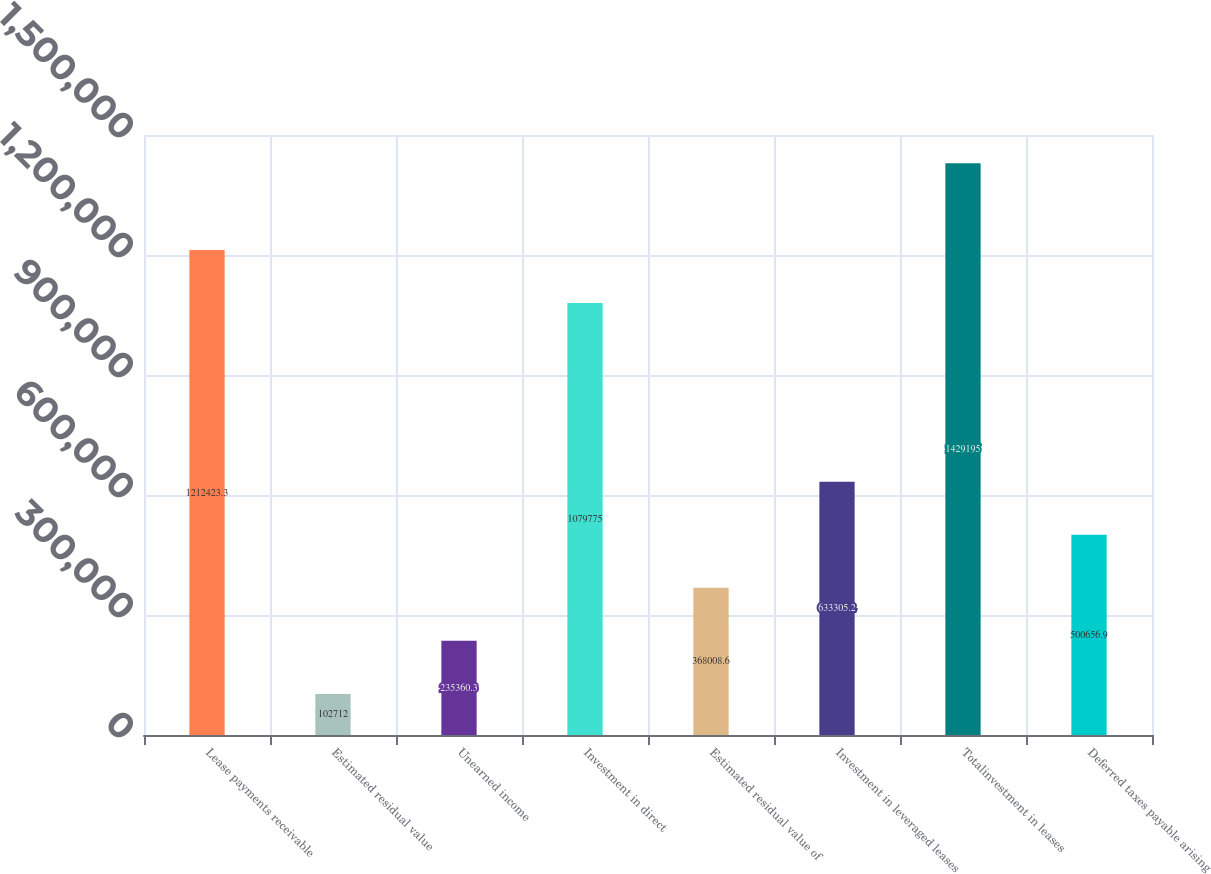<chart> <loc_0><loc_0><loc_500><loc_500><bar_chart><fcel>Lease payments receivable<fcel>Estimated residual value<fcel>Unearned income<fcel>Investment in direct<fcel>Estimated residual value of<fcel>Investment in leveraged leases<fcel>Totalinvestment in leases<fcel>Deferred taxes payable arising<nl><fcel>1.21242e+06<fcel>102712<fcel>235360<fcel>1.07978e+06<fcel>368009<fcel>633305<fcel>1.4292e+06<fcel>500657<nl></chart> 